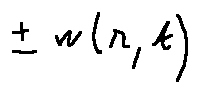Convert formula to latex. <formula><loc_0><loc_0><loc_500><loc_500>\pm w ( r , t )</formula> 